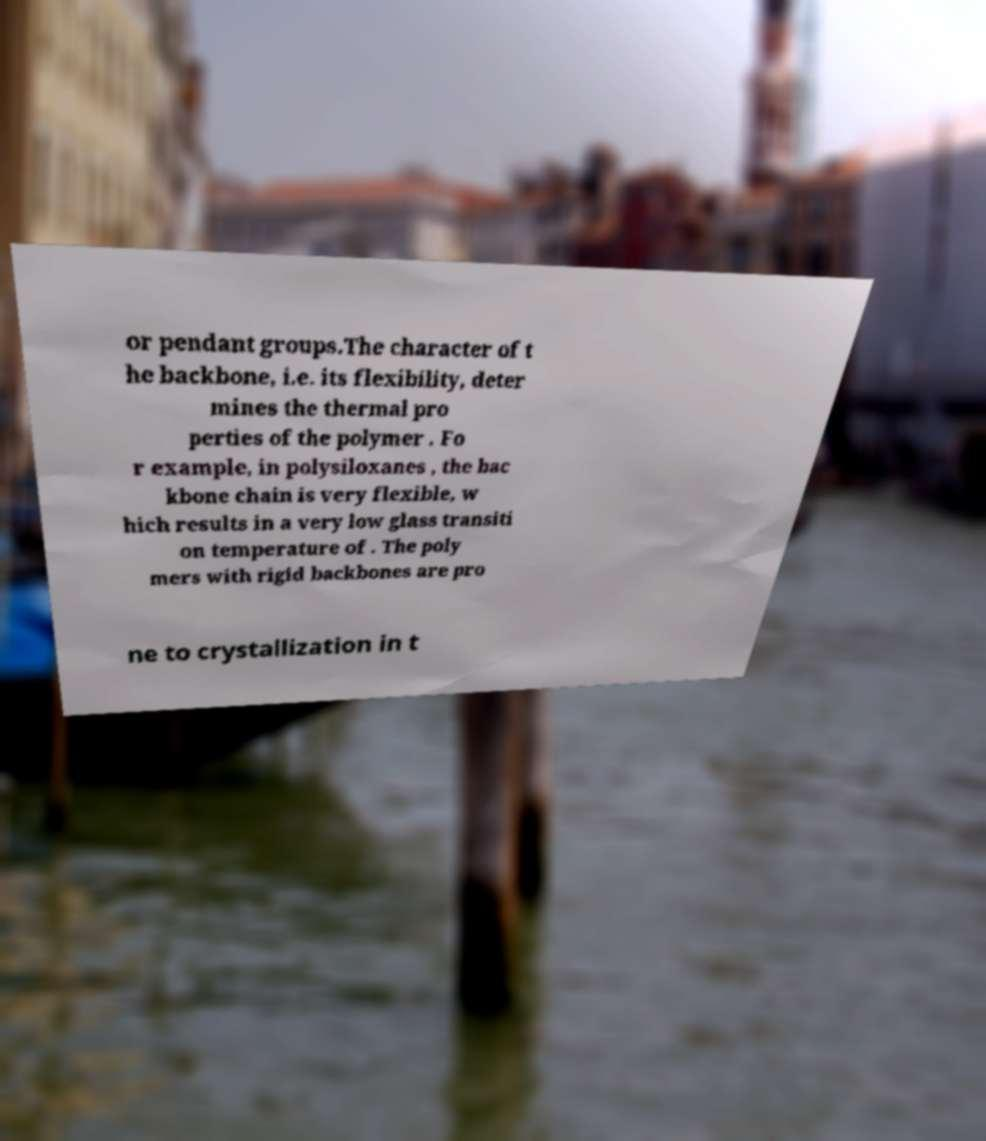For documentation purposes, I need the text within this image transcribed. Could you provide that? or pendant groups.The character of t he backbone, i.e. its flexibility, deter mines the thermal pro perties of the polymer . Fo r example, in polysiloxanes , the bac kbone chain is very flexible, w hich results in a very low glass transiti on temperature of . The poly mers with rigid backbones are pro ne to crystallization in t 